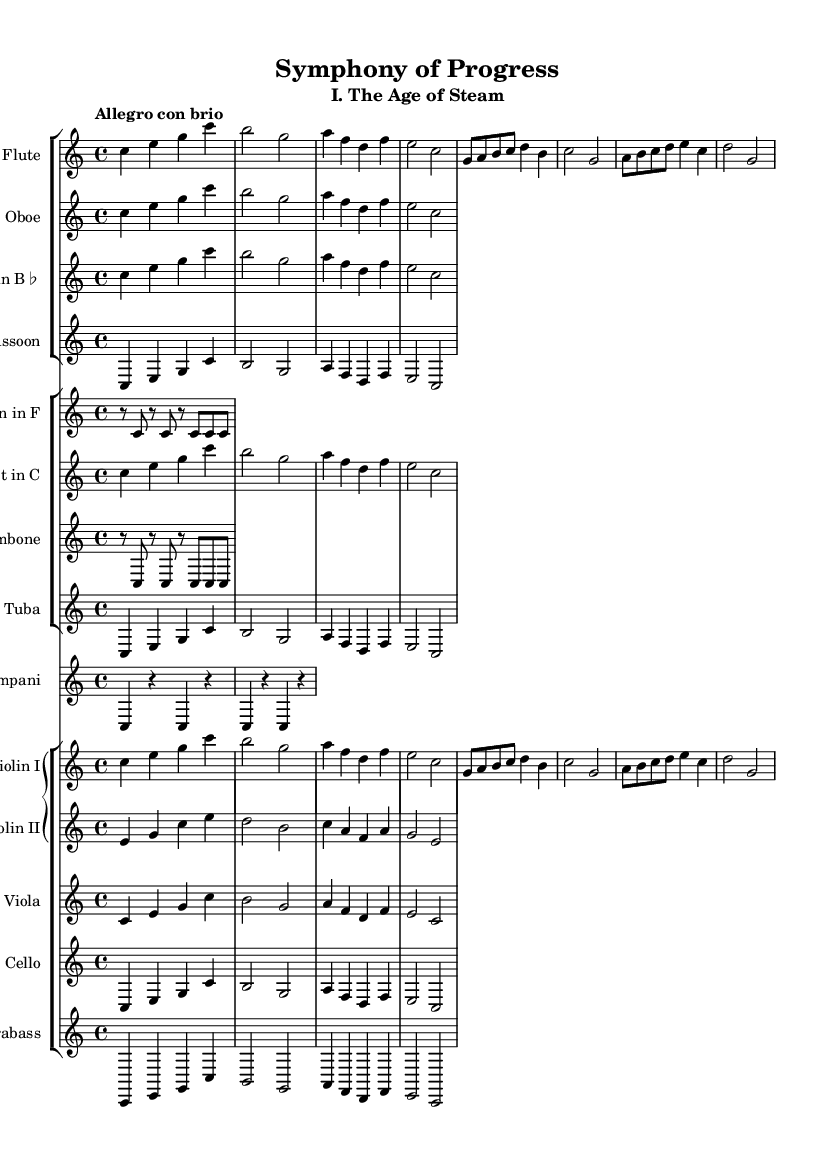What is the key signature of this music? The key signature is C major, which has no sharps or flats.
Answer: C major What is the time signature of this piece? The time signature shows that there are four beats in each measure, indicated by the "4/4" notation.
Answer: 4/4 What is the tempo marking for this symphony? The tempo marking is found at the beginning and indicates how fast the piece should be played; in this case, it is "Allegro con brio," which means lively and with spirit.
Answer: Allegro con brio How many instruments are featured in this symphony? By examining the score, we can count the number of unique staffs which represent different instruments; the total includes multiple woodwinds, brass, and strings, amounting to 11 different instruments.
Answer: 11 Which instrument does not include a melody in this excerpt? Reviewing the score, we can see that the percussion, specifically the timpani, provides rhythm and support but does not have a melodic line.
Answer: Timpani What section is labeled as "I. The Age of Steam"? This indicates that the movement of the symphony is part of a larger work, which is defined as the first section in this piece dedicated to the theme of industrial progress.
Answer: I. The Age of Steam What thematic element does this symphony reflect in the Romantic era? The specific theme reflects the advancements in industrialization and innovation, which was a significant characteristic of the Romantic era's focus on progress and change.
Answer: Industrial progress 